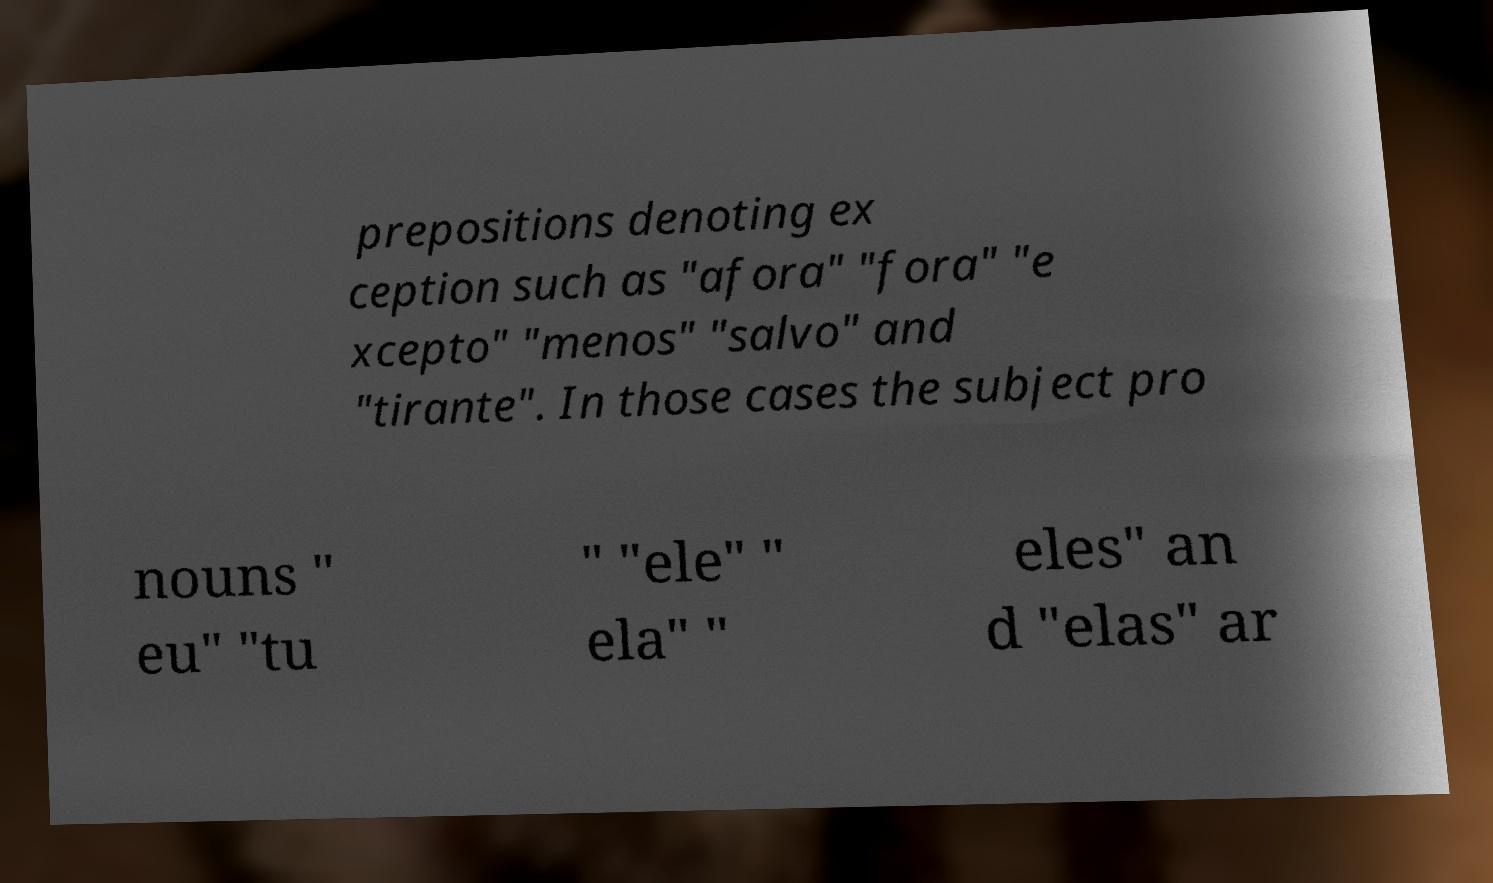Could you extract and type out the text from this image? prepositions denoting ex ception such as "afora" "fora" "e xcepto" "menos" "salvo" and "tirante". In those cases the subject pro nouns " eu" "tu " "ele" " ela" " eles" an d "elas" ar 